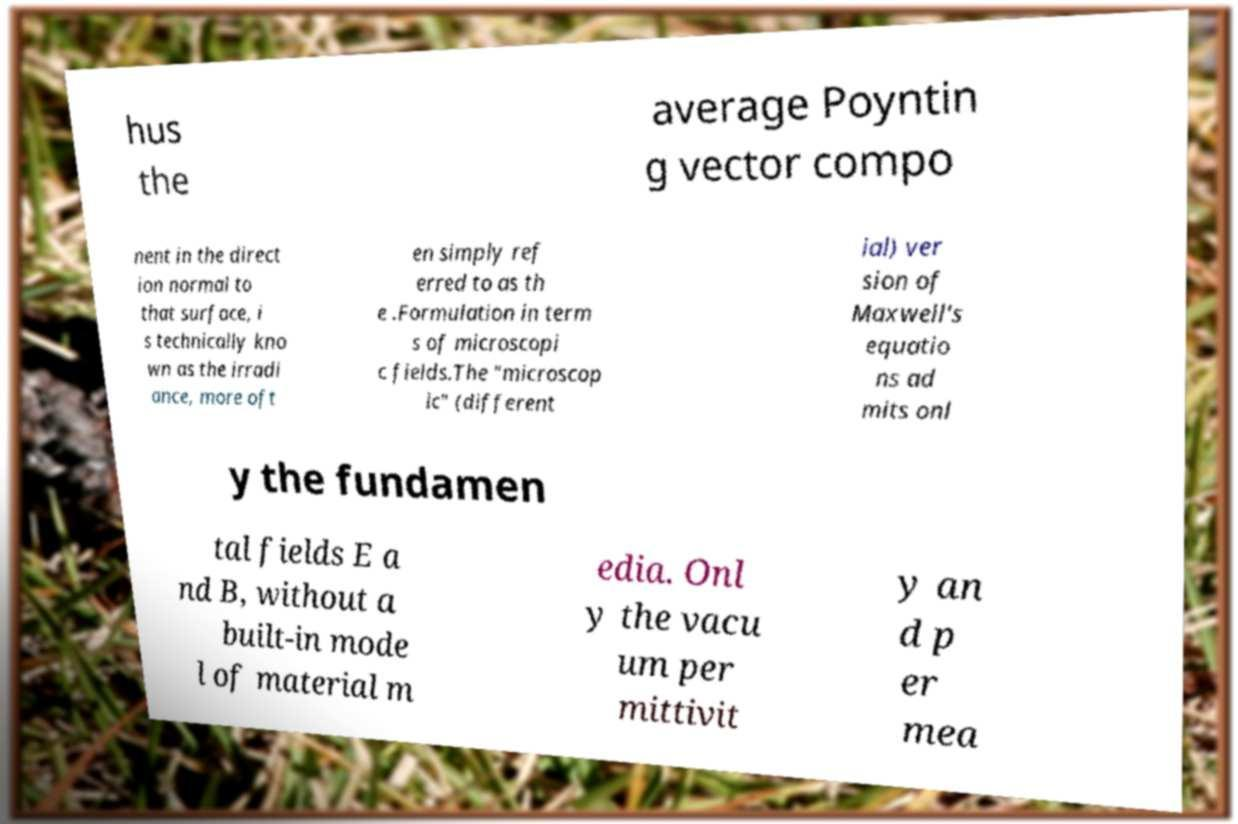For documentation purposes, I need the text within this image transcribed. Could you provide that? hus the average Poyntin g vector compo nent in the direct ion normal to that surface, i s technically kno wn as the irradi ance, more oft en simply ref erred to as th e .Formulation in term s of microscopi c fields.The "microscop ic" (different ial) ver sion of Maxwell's equatio ns ad mits onl y the fundamen tal fields E a nd B, without a built-in mode l of material m edia. Onl y the vacu um per mittivit y an d p er mea 